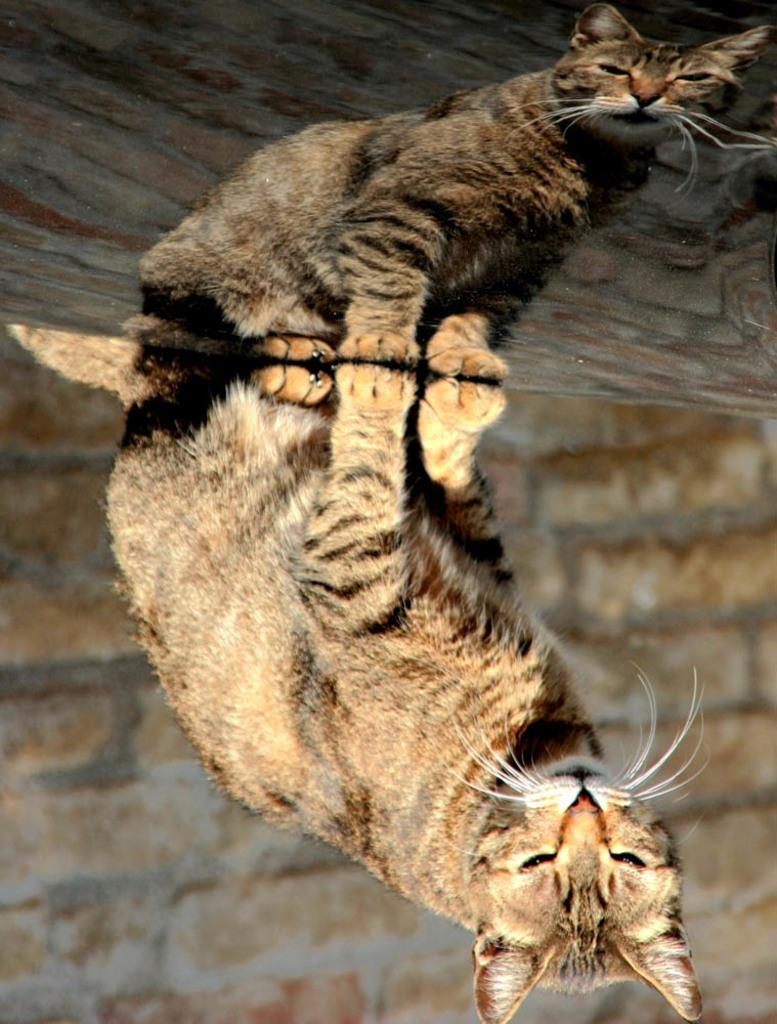What type of animal is in the image? There is a cat in the image. What is the background of the image? There is a wall in the image. Can you describe the reflection in the image? The image contains the reflection of a cat and a wall. Where is the store located in the image? There is no store present in the image. What type of twist can be seen in the image? There is no twist visible in the image. 